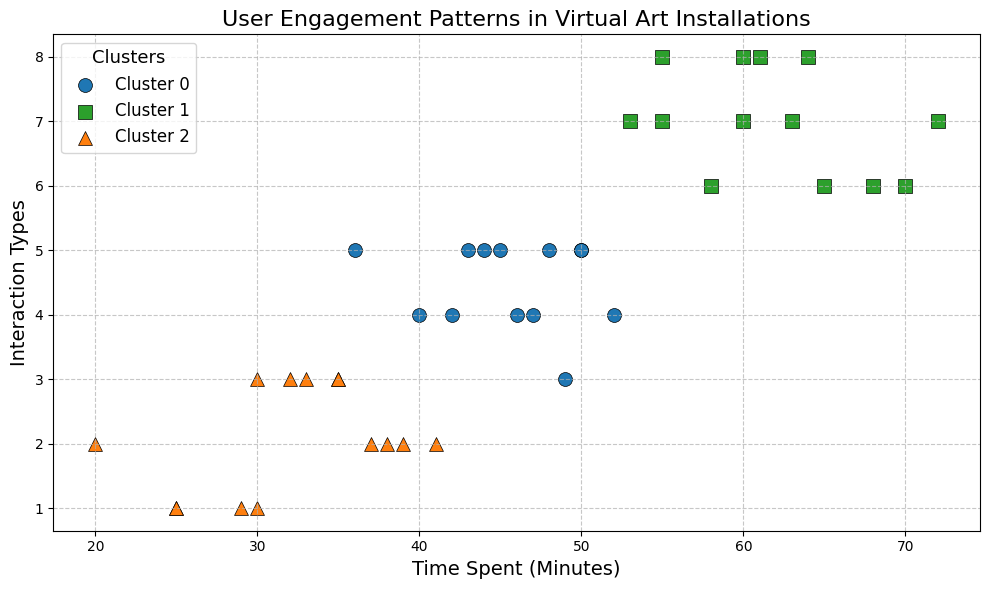What's the most common cluster for visitors who spend around 60 minutes interacting with the installation? To determine the most common cluster for visitors spending around 60 minutes, locate the data points near the 60-minute mark on the x-axis. Observe the cluster labels (colors and markers) for these data points. For instance, visitors spending 60 minutes and having 6, 7, or 8 interaction types likely fall into clusters 1 or 2 as indicated by their colors. Cluster 1 (color green) seems dominant for these data points.
Answer: Cluster 1 Which cluster has the highest average time spent by visitors? To find the cluster with the highest average time spent, identify the clusters on the plot and note the Time Spent values for each data point within these clusters. Calculate the average time spent within each cluster and compare. Cluster 2, which includes data points with higher Time Spent values, shows a higher average compared to other clusters.
Answer: Cluster 2 How do the revisit rates compare across the clusters? To compare revisit rates across clusters, observe the relative positioning of data points in terms of their revisit rate (color clustering and labels are not plotted, but an estimate can be inferred). Looking at clusters visually, you can estimate revisit rates shown by data points within each cluster. Cluster 0 with lower Time Spent and Interaction Types tends to have lower revisit rates, while Clusters 1 and 2 show higher revisit rates.
Answer: Cluster 0 has the lowest, Clusters 1 and 2 higher What is the relationship between interaction types and cluster membership? Identify the number of interaction types (y-axis) for each cluster by observing the vertical spread of data points in each cluster. Compare how clustered data points with different markers are spread along the interaction types axis. Visitors in clusters 1 and 2 engage in a wider range of interaction types compared to Cluster 0.
Answer: Cluster 1 and 2 have higher interaction types Which cluster does the visitor who spends the most time belong to? Locate the data point with the highest Time Spent on the x-axis and identify its cluster membership using the color and marker type. The visitor spending the most time (72 minutes) falls into Cluster 2, identified by the respective color/marker for that cluster.
Answer: Cluster 2 What is the spread of Time Spent values within Cluster 0? Identify data points within Cluster 0 by their color/marker. Observe the range of values on the x-axis corresponding to these points. Cluster 0 contains visitors with Time Spent ranging approximately from 20 to 40 minutes.
Answer: 20 to 40 minutes Compare the interaction types for the visitors in Cluster 2 and Cluster 0. Locate and note interaction types (y-axis) for data points within Cluster 2 and Cluster 0. Compare the vertical spread for these clusters. Visitors in Cluster 2 have higher interaction types, typically between 5 and 8, while Cluster 0 shows lower interaction types, typically between 1 and 3.
Answer: Cluster 2 has higher interaction types What can you infer about clusters based on both time spent and interaction types? By observing both Time Spent (x-axis) and Interaction Types (y-axis) for clusters, we can identify behavioral patterns. Cluster 0 includes visitors with lower engagement (time and interactions). Cluster 1 shows moderate engagement, and Cluster 2 comprises visitors with the highest engagement in both aspects.
Answer: Clusters 1 and 2 show higher engagement Which cluster includes visitors who don't revisit the installation? Locate data points with a revisit rate of 0 and note their cluster membership based on color/marker. Observing the y-axis (interaction types), these data points fall into Cluster 0, indicating no revisits.
Answer: Cluster 0 